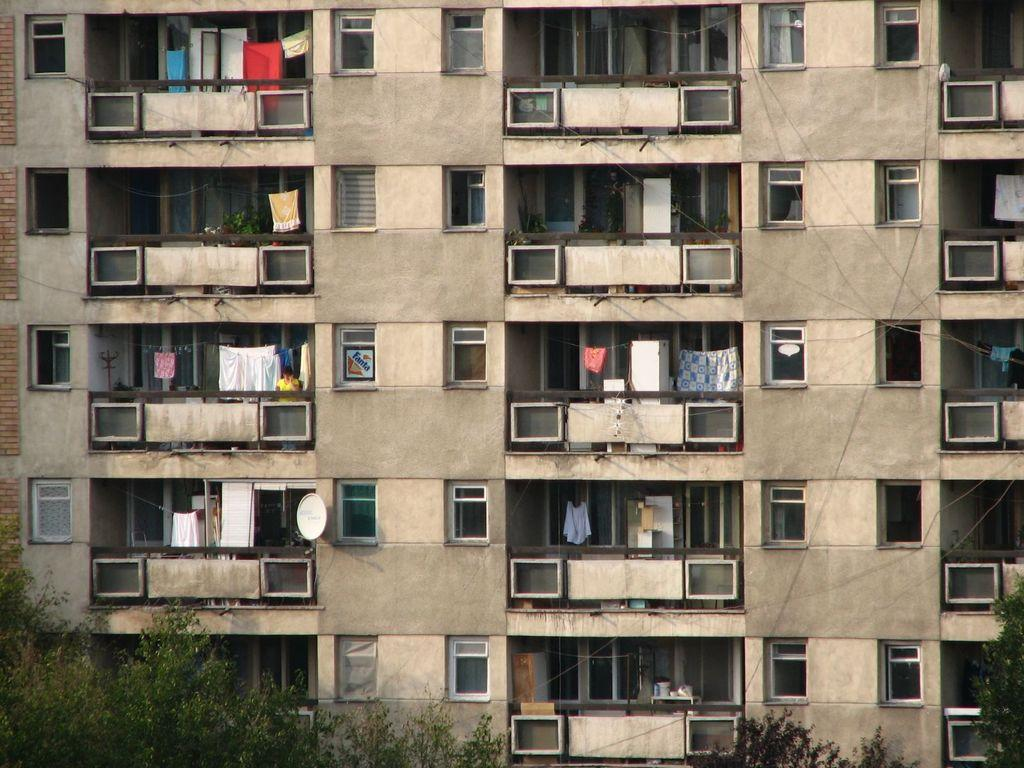What type of structure is present in the image? There is a building in the image. What are some features of the building? The building has walls, windows, and balconies. What can be seen hanging from the ropes in the image? There are clothes hanging from the ropes in the image. What type of communication device is present on the building? There is a dish antenna in the image. What type of vegetation is visible at the bottom of the image? There are branches with leaves at the bottom of the image. What is the income of the person wearing the skirt in the image? There is no person wearing a skirt in the image, as the provided facts do not mention any clothing items. 